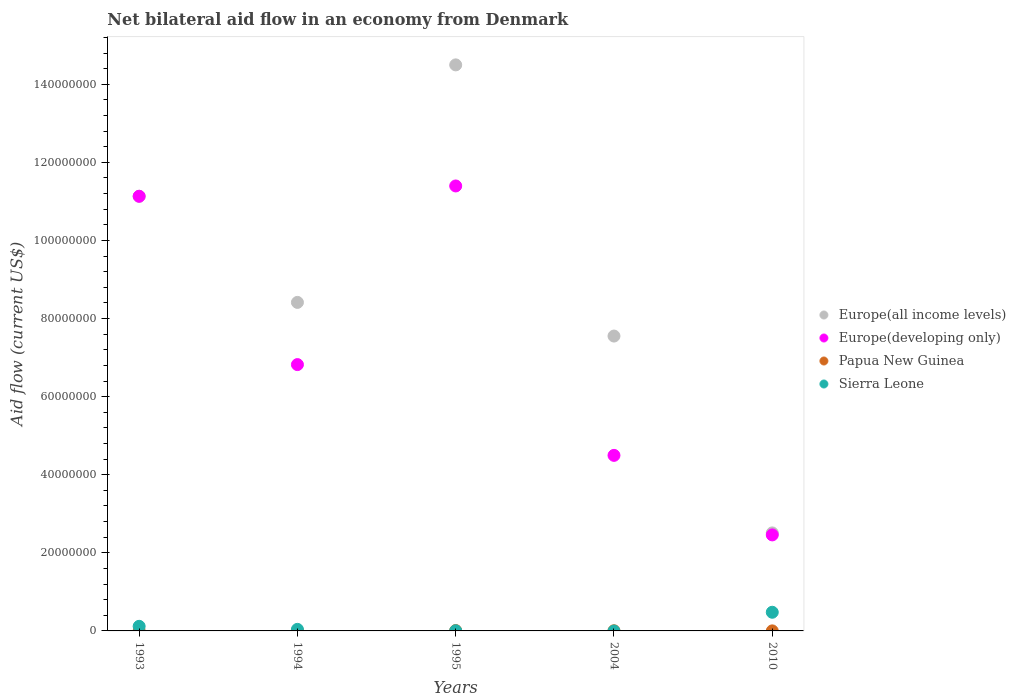What is the net bilateral aid flow in Europe(developing only) in 2004?
Offer a very short reply. 4.50e+07. Across all years, what is the maximum net bilateral aid flow in Europe(all income levels)?
Your response must be concise. 1.45e+08. Across all years, what is the minimum net bilateral aid flow in Papua New Guinea?
Provide a short and direct response. 10000. In which year was the net bilateral aid flow in Sierra Leone maximum?
Provide a succinct answer. 2010. What is the total net bilateral aid flow in Europe(all income levels) in the graph?
Make the answer very short. 4.41e+08. What is the difference between the net bilateral aid flow in Europe(developing only) in 1995 and that in 2004?
Your answer should be compact. 6.90e+07. What is the difference between the net bilateral aid flow in Europe(developing only) in 1993 and the net bilateral aid flow in Europe(all income levels) in 2010?
Ensure brevity in your answer.  8.62e+07. What is the average net bilateral aid flow in Papua New Guinea per year?
Your answer should be very brief. 3.20e+04. In how many years, is the net bilateral aid flow in Sierra Leone greater than 16000000 US$?
Keep it short and to the point. 0. What is the difference between the highest and the second highest net bilateral aid flow in Europe(developing only)?
Provide a succinct answer. 2.64e+06. What is the difference between the highest and the lowest net bilateral aid flow in Europe(all income levels)?
Your answer should be compact. 1.20e+08. Is the sum of the net bilateral aid flow in Europe(all income levels) in 1993 and 2004 greater than the maximum net bilateral aid flow in Sierra Leone across all years?
Give a very brief answer. Yes. Is it the case that in every year, the sum of the net bilateral aid flow in Europe(all income levels) and net bilateral aid flow in Papua New Guinea  is greater than the sum of net bilateral aid flow in Sierra Leone and net bilateral aid flow in Europe(developing only)?
Your answer should be very brief. Yes. Is the net bilateral aid flow in Europe(developing only) strictly greater than the net bilateral aid flow in Papua New Guinea over the years?
Make the answer very short. Yes. Is the net bilateral aid flow in Europe(developing only) strictly less than the net bilateral aid flow in Papua New Guinea over the years?
Offer a very short reply. No. What is the difference between two consecutive major ticks on the Y-axis?
Make the answer very short. 2.00e+07. Are the values on the major ticks of Y-axis written in scientific E-notation?
Provide a short and direct response. No. Does the graph contain any zero values?
Provide a succinct answer. Yes. Does the graph contain grids?
Your answer should be very brief. No. How many legend labels are there?
Ensure brevity in your answer.  4. What is the title of the graph?
Your answer should be compact. Net bilateral aid flow in an economy from Denmark. Does "Swaziland" appear as one of the legend labels in the graph?
Make the answer very short. No. What is the label or title of the Y-axis?
Ensure brevity in your answer.  Aid flow (current US$). What is the Aid flow (current US$) of Europe(all income levels) in 1993?
Ensure brevity in your answer.  1.11e+08. What is the Aid flow (current US$) in Europe(developing only) in 1993?
Your answer should be compact. 1.11e+08. What is the Aid flow (current US$) of Sierra Leone in 1993?
Provide a short and direct response. 1.18e+06. What is the Aid flow (current US$) in Europe(all income levels) in 1994?
Offer a very short reply. 8.41e+07. What is the Aid flow (current US$) of Europe(developing only) in 1994?
Provide a short and direct response. 6.82e+07. What is the Aid flow (current US$) of Papua New Guinea in 1994?
Ensure brevity in your answer.  10000. What is the Aid flow (current US$) in Europe(all income levels) in 1995?
Provide a succinct answer. 1.45e+08. What is the Aid flow (current US$) of Europe(developing only) in 1995?
Offer a terse response. 1.14e+08. What is the Aid flow (current US$) in Papua New Guinea in 1995?
Keep it short and to the point. 9.00e+04. What is the Aid flow (current US$) of Sierra Leone in 1995?
Offer a very short reply. 4.00e+04. What is the Aid flow (current US$) of Europe(all income levels) in 2004?
Your answer should be very brief. 7.55e+07. What is the Aid flow (current US$) in Europe(developing only) in 2004?
Offer a terse response. 4.50e+07. What is the Aid flow (current US$) of Sierra Leone in 2004?
Your answer should be very brief. 0. What is the Aid flow (current US$) in Europe(all income levels) in 2010?
Your answer should be compact. 2.51e+07. What is the Aid flow (current US$) of Europe(developing only) in 2010?
Your response must be concise. 2.46e+07. What is the Aid flow (current US$) in Sierra Leone in 2010?
Keep it short and to the point. 4.78e+06. Across all years, what is the maximum Aid flow (current US$) of Europe(all income levels)?
Provide a succinct answer. 1.45e+08. Across all years, what is the maximum Aid flow (current US$) in Europe(developing only)?
Provide a short and direct response. 1.14e+08. Across all years, what is the maximum Aid flow (current US$) of Papua New Guinea?
Ensure brevity in your answer.  9.00e+04. Across all years, what is the maximum Aid flow (current US$) of Sierra Leone?
Your answer should be compact. 4.78e+06. Across all years, what is the minimum Aid flow (current US$) in Europe(all income levels)?
Your response must be concise. 2.51e+07. Across all years, what is the minimum Aid flow (current US$) in Europe(developing only)?
Provide a succinct answer. 2.46e+07. Across all years, what is the minimum Aid flow (current US$) of Papua New Guinea?
Keep it short and to the point. 10000. Across all years, what is the minimum Aid flow (current US$) of Sierra Leone?
Keep it short and to the point. 0. What is the total Aid flow (current US$) in Europe(all income levels) in the graph?
Offer a very short reply. 4.41e+08. What is the total Aid flow (current US$) of Europe(developing only) in the graph?
Ensure brevity in your answer.  3.63e+08. What is the total Aid flow (current US$) of Papua New Guinea in the graph?
Give a very brief answer. 1.60e+05. What is the total Aid flow (current US$) of Sierra Leone in the graph?
Provide a succinct answer. 6.40e+06. What is the difference between the Aid flow (current US$) in Europe(all income levels) in 1993 and that in 1994?
Provide a short and direct response. 2.72e+07. What is the difference between the Aid flow (current US$) of Europe(developing only) in 1993 and that in 1994?
Provide a succinct answer. 4.31e+07. What is the difference between the Aid flow (current US$) of Papua New Guinea in 1993 and that in 1994?
Give a very brief answer. 0. What is the difference between the Aid flow (current US$) of Sierra Leone in 1993 and that in 1994?
Offer a terse response. 7.80e+05. What is the difference between the Aid flow (current US$) of Europe(all income levels) in 1993 and that in 1995?
Offer a very short reply. -3.36e+07. What is the difference between the Aid flow (current US$) in Europe(developing only) in 1993 and that in 1995?
Provide a short and direct response. -2.64e+06. What is the difference between the Aid flow (current US$) of Sierra Leone in 1993 and that in 1995?
Provide a short and direct response. 1.14e+06. What is the difference between the Aid flow (current US$) in Europe(all income levels) in 1993 and that in 2004?
Offer a very short reply. 3.58e+07. What is the difference between the Aid flow (current US$) in Europe(developing only) in 1993 and that in 2004?
Ensure brevity in your answer.  6.64e+07. What is the difference between the Aid flow (current US$) of Europe(all income levels) in 1993 and that in 2010?
Provide a succinct answer. 8.62e+07. What is the difference between the Aid flow (current US$) of Europe(developing only) in 1993 and that in 2010?
Provide a short and direct response. 8.67e+07. What is the difference between the Aid flow (current US$) in Sierra Leone in 1993 and that in 2010?
Provide a short and direct response. -3.60e+06. What is the difference between the Aid flow (current US$) of Europe(all income levels) in 1994 and that in 1995?
Offer a terse response. -6.08e+07. What is the difference between the Aid flow (current US$) of Europe(developing only) in 1994 and that in 1995?
Give a very brief answer. -4.58e+07. What is the difference between the Aid flow (current US$) in Papua New Guinea in 1994 and that in 1995?
Your answer should be very brief. -8.00e+04. What is the difference between the Aid flow (current US$) of Sierra Leone in 1994 and that in 1995?
Offer a terse response. 3.60e+05. What is the difference between the Aid flow (current US$) of Europe(all income levels) in 1994 and that in 2004?
Offer a very short reply. 8.62e+06. What is the difference between the Aid flow (current US$) of Europe(developing only) in 1994 and that in 2004?
Provide a succinct answer. 2.32e+07. What is the difference between the Aid flow (current US$) in Papua New Guinea in 1994 and that in 2004?
Your response must be concise. -3.00e+04. What is the difference between the Aid flow (current US$) in Europe(all income levels) in 1994 and that in 2010?
Your answer should be compact. 5.90e+07. What is the difference between the Aid flow (current US$) of Europe(developing only) in 1994 and that in 2010?
Make the answer very short. 4.36e+07. What is the difference between the Aid flow (current US$) of Papua New Guinea in 1994 and that in 2010?
Provide a succinct answer. 0. What is the difference between the Aid flow (current US$) of Sierra Leone in 1994 and that in 2010?
Give a very brief answer. -4.38e+06. What is the difference between the Aid flow (current US$) of Europe(all income levels) in 1995 and that in 2004?
Your response must be concise. 6.94e+07. What is the difference between the Aid flow (current US$) of Europe(developing only) in 1995 and that in 2004?
Ensure brevity in your answer.  6.90e+07. What is the difference between the Aid flow (current US$) in Papua New Guinea in 1995 and that in 2004?
Provide a short and direct response. 5.00e+04. What is the difference between the Aid flow (current US$) of Europe(all income levels) in 1995 and that in 2010?
Provide a short and direct response. 1.20e+08. What is the difference between the Aid flow (current US$) of Europe(developing only) in 1995 and that in 2010?
Offer a terse response. 8.94e+07. What is the difference between the Aid flow (current US$) of Papua New Guinea in 1995 and that in 2010?
Offer a terse response. 8.00e+04. What is the difference between the Aid flow (current US$) in Sierra Leone in 1995 and that in 2010?
Provide a succinct answer. -4.74e+06. What is the difference between the Aid flow (current US$) of Europe(all income levels) in 2004 and that in 2010?
Your response must be concise. 5.04e+07. What is the difference between the Aid flow (current US$) of Europe(developing only) in 2004 and that in 2010?
Give a very brief answer. 2.04e+07. What is the difference between the Aid flow (current US$) in Papua New Guinea in 2004 and that in 2010?
Keep it short and to the point. 3.00e+04. What is the difference between the Aid flow (current US$) of Europe(all income levels) in 1993 and the Aid flow (current US$) of Europe(developing only) in 1994?
Keep it short and to the point. 4.31e+07. What is the difference between the Aid flow (current US$) of Europe(all income levels) in 1993 and the Aid flow (current US$) of Papua New Guinea in 1994?
Ensure brevity in your answer.  1.11e+08. What is the difference between the Aid flow (current US$) in Europe(all income levels) in 1993 and the Aid flow (current US$) in Sierra Leone in 1994?
Your response must be concise. 1.11e+08. What is the difference between the Aid flow (current US$) in Europe(developing only) in 1993 and the Aid flow (current US$) in Papua New Guinea in 1994?
Your response must be concise. 1.11e+08. What is the difference between the Aid flow (current US$) in Europe(developing only) in 1993 and the Aid flow (current US$) in Sierra Leone in 1994?
Offer a very short reply. 1.11e+08. What is the difference between the Aid flow (current US$) of Papua New Guinea in 1993 and the Aid flow (current US$) of Sierra Leone in 1994?
Your answer should be compact. -3.90e+05. What is the difference between the Aid flow (current US$) in Europe(all income levels) in 1993 and the Aid flow (current US$) in Europe(developing only) in 1995?
Ensure brevity in your answer.  -2.64e+06. What is the difference between the Aid flow (current US$) of Europe(all income levels) in 1993 and the Aid flow (current US$) of Papua New Guinea in 1995?
Give a very brief answer. 1.11e+08. What is the difference between the Aid flow (current US$) in Europe(all income levels) in 1993 and the Aid flow (current US$) in Sierra Leone in 1995?
Keep it short and to the point. 1.11e+08. What is the difference between the Aid flow (current US$) in Europe(developing only) in 1993 and the Aid flow (current US$) in Papua New Guinea in 1995?
Give a very brief answer. 1.11e+08. What is the difference between the Aid flow (current US$) in Europe(developing only) in 1993 and the Aid flow (current US$) in Sierra Leone in 1995?
Offer a terse response. 1.11e+08. What is the difference between the Aid flow (current US$) in Papua New Guinea in 1993 and the Aid flow (current US$) in Sierra Leone in 1995?
Give a very brief answer. -3.00e+04. What is the difference between the Aid flow (current US$) in Europe(all income levels) in 1993 and the Aid flow (current US$) in Europe(developing only) in 2004?
Provide a short and direct response. 6.64e+07. What is the difference between the Aid flow (current US$) of Europe(all income levels) in 1993 and the Aid flow (current US$) of Papua New Guinea in 2004?
Make the answer very short. 1.11e+08. What is the difference between the Aid flow (current US$) in Europe(developing only) in 1993 and the Aid flow (current US$) in Papua New Guinea in 2004?
Ensure brevity in your answer.  1.11e+08. What is the difference between the Aid flow (current US$) in Europe(all income levels) in 1993 and the Aid flow (current US$) in Europe(developing only) in 2010?
Provide a short and direct response. 8.67e+07. What is the difference between the Aid flow (current US$) of Europe(all income levels) in 1993 and the Aid flow (current US$) of Papua New Guinea in 2010?
Your answer should be compact. 1.11e+08. What is the difference between the Aid flow (current US$) of Europe(all income levels) in 1993 and the Aid flow (current US$) of Sierra Leone in 2010?
Make the answer very short. 1.07e+08. What is the difference between the Aid flow (current US$) in Europe(developing only) in 1993 and the Aid flow (current US$) in Papua New Guinea in 2010?
Your answer should be very brief. 1.11e+08. What is the difference between the Aid flow (current US$) of Europe(developing only) in 1993 and the Aid flow (current US$) of Sierra Leone in 2010?
Give a very brief answer. 1.07e+08. What is the difference between the Aid flow (current US$) in Papua New Guinea in 1993 and the Aid flow (current US$) in Sierra Leone in 2010?
Your answer should be compact. -4.77e+06. What is the difference between the Aid flow (current US$) in Europe(all income levels) in 1994 and the Aid flow (current US$) in Europe(developing only) in 1995?
Ensure brevity in your answer.  -2.98e+07. What is the difference between the Aid flow (current US$) in Europe(all income levels) in 1994 and the Aid flow (current US$) in Papua New Guinea in 1995?
Your response must be concise. 8.40e+07. What is the difference between the Aid flow (current US$) in Europe(all income levels) in 1994 and the Aid flow (current US$) in Sierra Leone in 1995?
Offer a terse response. 8.41e+07. What is the difference between the Aid flow (current US$) in Europe(developing only) in 1994 and the Aid flow (current US$) in Papua New Guinea in 1995?
Ensure brevity in your answer.  6.81e+07. What is the difference between the Aid flow (current US$) in Europe(developing only) in 1994 and the Aid flow (current US$) in Sierra Leone in 1995?
Keep it short and to the point. 6.82e+07. What is the difference between the Aid flow (current US$) of Papua New Guinea in 1994 and the Aid flow (current US$) of Sierra Leone in 1995?
Offer a terse response. -3.00e+04. What is the difference between the Aid flow (current US$) in Europe(all income levels) in 1994 and the Aid flow (current US$) in Europe(developing only) in 2004?
Provide a short and direct response. 3.92e+07. What is the difference between the Aid flow (current US$) in Europe(all income levels) in 1994 and the Aid flow (current US$) in Papua New Guinea in 2004?
Your answer should be compact. 8.41e+07. What is the difference between the Aid flow (current US$) in Europe(developing only) in 1994 and the Aid flow (current US$) in Papua New Guinea in 2004?
Make the answer very short. 6.82e+07. What is the difference between the Aid flow (current US$) in Europe(all income levels) in 1994 and the Aid flow (current US$) in Europe(developing only) in 2010?
Make the answer very short. 5.96e+07. What is the difference between the Aid flow (current US$) in Europe(all income levels) in 1994 and the Aid flow (current US$) in Papua New Guinea in 2010?
Make the answer very short. 8.41e+07. What is the difference between the Aid flow (current US$) in Europe(all income levels) in 1994 and the Aid flow (current US$) in Sierra Leone in 2010?
Provide a succinct answer. 7.94e+07. What is the difference between the Aid flow (current US$) of Europe(developing only) in 1994 and the Aid flow (current US$) of Papua New Guinea in 2010?
Give a very brief answer. 6.82e+07. What is the difference between the Aid flow (current US$) in Europe(developing only) in 1994 and the Aid flow (current US$) in Sierra Leone in 2010?
Your response must be concise. 6.34e+07. What is the difference between the Aid flow (current US$) in Papua New Guinea in 1994 and the Aid flow (current US$) in Sierra Leone in 2010?
Provide a short and direct response. -4.77e+06. What is the difference between the Aid flow (current US$) in Europe(all income levels) in 1995 and the Aid flow (current US$) in Europe(developing only) in 2004?
Provide a succinct answer. 1.00e+08. What is the difference between the Aid flow (current US$) of Europe(all income levels) in 1995 and the Aid flow (current US$) of Papua New Guinea in 2004?
Keep it short and to the point. 1.45e+08. What is the difference between the Aid flow (current US$) in Europe(developing only) in 1995 and the Aid flow (current US$) in Papua New Guinea in 2004?
Offer a terse response. 1.14e+08. What is the difference between the Aid flow (current US$) of Europe(all income levels) in 1995 and the Aid flow (current US$) of Europe(developing only) in 2010?
Ensure brevity in your answer.  1.20e+08. What is the difference between the Aid flow (current US$) in Europe(all income levels) in 1995 and the Aid flow (current US$) in Papua New Guinea in 2010?
Offer a very short reply. 1.45e+08. What is the difference between the Aid flow (current US$) of Europe(all income levels) in 1995 and the Aid flow (current US$) of Sierra Leone in 2010?
Make the answer very short. 1.40e+08. What is the difference between the Aid flow (current US$) in Europe(developing only) in 1995 and the Aid flow (current US$) in Papua New Guinea in 2010?
Your answer should be compact. 1.14e+08. What is the difference between the Aid flow (current US$) in Europe(developing only) in 1995 and the Aid flow (current US$) in Sierra Leone in 2010?
Offer a very short reply. 1.09e+08. What is the difference between the Aid flow (current US$) in Papua New Guinea in 1995 and the Aid flow (current US$) in Sierra Leone in 2010?
Give a very brief answer. -4.69e+06. What is the difference between the Aid flow (current US$) of Europe(all income levels) in 2004 and the Aid flow (current US$) of Europe(developing only) in 2010?
Your answer should be compact. 5.09e+07. What is the difference between the Aid flow (current US$) in Europe(all income levels) in 2004 and the Aid flow (current US$) in Papua New Guinea in 2010?
Make the answer very short. 7.55e+07. What is the difference between the Aid flow (current US$) in Europe(all income levels) in 2004 and the Aid flow (current US$) in Sierra Leone in 2010?
Provide a succinct answer. 7.07e+07. What is the difference between the Aid flow (current US$) in Europe(developing only) in 2004 and the Aid flow (current US$) in Papua New Guinea in 2010?
Your response must be concise. 4.50e+07. What is the difference between the Aid flow (current US$) in Europe(developing only) in 2004 and the Aid flow (current US$) in Sierra Leone in 2010?
Your answer should be compact. 4.02e+07. What is the difference between the Aid flow (current US$) of Papua New Guinea in 2004 and the Aid flow (current US$) of Sierra Leone in 2010?
Your answer should be very brief. -4.74e+06. What is the average Aid flow (current US$) of Europe(all income levels) per year?
Your answer should be very brief. 8.82e+07. What is the average Aid flow (current US$) of Europe(developing only) per year?
Give a very brief answer. 7.26e+07. What is the average Aid flow (current US$) of Papua New Guinea per year?
Your response must be concise. 3.20e+04. What is the average Aid flow (current US$) of Sierra Leone per year?
Your answer should be compact. 1.28e+06. In the year 1993, what is the difference between the Aid flow (current US$) in Europe(all income levels) and Aid flow (current US$) in Europe(developing only)?
Offer a terse response. 0. In the year 1993, what is the difference between the Aid flow (current US$) in Europe(all income levels) and Aid flow (current US$) in Papua New Guinea?
Make the answer very short. 1.11e+08. In the year 1993, what is the difference between the Aid flow (current US$) in Europe(all income levels) and Aid flow (current US$) in Sierra Leone?
Your answer should be compact. 1.10e+08. In the year 1993, what is the difference between the Aid flow (current US$) in Europe(developing only) and Aid flow (current US$) in Papua New Guinea?
Your answer should be very brief. 1.11e+08. In the year 1993, what is the difference between the Aid flow (current US$) of Europe(developing only) and Aid flow (current US$) of Sierra Leone?
Ensure brevity in your answer.  1.10e+08. In the year 1993, what is the difference between the Aid flow (current US$) in Papua New Guinea and Aid flow (current US$) in Sierra Leone?
Provide a short and direct response. -1.17e+06. In the year 1994, what is the difference between the Aid flow (current US$) in Europe(all income levels) and Aid flow (current US$) in Europe(developing only)?
Provide a short and direct response. 1.59e+07. In the year 1994, what is the difference between the Aid flow (current US$) in Europe(all income levels) and Aid flow (current US$) in Papua New Guinea?
Your response must be concise. 8.41e+07. In the year 1994, what is the difference between the Aid flow (current US$) in Europe(all income levels) and Aid flow (current US$) in Sierra Leone?
Your response must be concise. 8.37e+07. In the year 1994, what is the difference between the Aid flow (current US$) in Europe(developing only) and Aid flow (current US$) in Papua New Guinea?
Your response must be concise. 6.82e+07. In the year 1994, what is the difference between the Aid flow (current US$) in Europe(developing only) and Aid flow (current US$) in Sierra Leone?
Your answer should be very brief. 6.78e+07. In the year 1994, what is the difference between the Aid flow (current US$) in Papua New Guinea and Aid flow (current US$) in Sierra Leone?
Provide a succinct answer. -3.90e+05. In the year 1995, what is the difference between the Aid flow (current US$) in Europe(all income levels) and Aid flow (current US$) in Europe(developing only)?
Give a very brief answer. 3.10e+07. In the year 1995, what is the difference between the Aid flow (current US$) of Europe(all income levels) and Aid flow (current US$) of Papua New Guinea?
Give a very brief answer. 1.45e+08. In the year 1995, what is the difference between the Aid flow (current US$) of Europe(all income levels) and Aid flow (current US$) of Sierra Leone?
Keep it short and to the point. 1.45e+08. In the year 1995, what is the difference between the Aid flow (current US$) in Europe(developing only) and Aid flow (current US$) in Papua New Guinea?
Your response must be concise. 1.14e+08. In the year 1995, what is the difference between the Aid flow (current US$) in Europe(developing only) and Aid flow (current US$) in Sierra Leone?
Your response must be concise. 1.14e+08. In the year 1995, what is the difference between the Aid flow (current US$) in Papua New Guinea and Aid flow (current US$) in Sierra Leone?
Ensure brevity in your answer.  5.00e+04. In the year 2004, what is the difference between the Aid flow (current US$) in Europe(all income levels) and Aid flow (current US$) in Europe(developing only)?
Your response must be concise. 3.06e+07. In the year 2004, what is the difference between the Aid flow (current US$) in Europe(all income levels) and Aid flow (current US$) in Papua New Guinea?
Ensure brevity in your answer.  7.55e+07. In the year 2004, what is the difference between the Aid flow (current US$) in Europe(developing only) and Aid flow (current US$) in Papua New Guinea?
Your answer should be compact. 4.49e+07. In the year 2010, what is the difference between the Aid flow (current US$) in Europe(all income levels) and Aid flow (current US$) in Europe(developing only)?
Keep it short and to the point. 5.10e+05. In the year 2010, what is the difference between the Aid flow (current US$) in Europe(all income levels) and Aid flow (current US$) in Papua New Guinea?
Offer a very short reply. 2.51e+07. In the year 2010, what is the difference between the Aid flow (current US$) in Europe(all income levels) and Aid flow (current US$) in Sierra Leone?
Keep it short and to the point. 2.03e+07. In the year 2010, what is the difference between the Aid flow (current US$) in Europe(developing only) and Aid flow (current US$) in Papua New Guinea?
Ensure brevity in your answer.  2.46e+07. In the year 2010, what is the difference between the Aid flow (current US$) of Europe(developing only) and Aid flow (current US$) of Sierra Leone?
Provide a succinct answer. 1.98e+07. In the year 2010, what is the difference between the Aid flow (current US$) of Papua New Guinea and Aid flow (current US$) of Sierra Leone?
Your response must be concise. -4.77e+06. What is the ratio of the Aid flow (current US$) in Europe(all income levels) in 1993 to that in 1994?
Your answer should be compact. 1.32. What is the ratio of the Aid flow (current US$) of Europe(developing only) in 1993 to that in 1994?
Provide a succinct answer. 1.63. What is the ratio of the Aid flow (current US$) of Papua New Guinea in 1993 to that in 1994?
Your response must be concise. 1. What is the ratio of the Aid flow (current US$) in Sierra Leone in 1993 to that in 1994?
Give a very brief answer. 2.95. What is the ratio of the Aid flow (current US$) of Europe(all income levels) in 1993 to that in 1995?
Keep it short and to the point. 0.77. What is the ratio of the Aid flow (current US$) of Europe(developing only) in 1993 to that in 1995?
Keep it short and to the point. 0.98. What is the ratio of the Aid flow (current US$) in Papua New Guinea in 1993 to that in 1995?
Your answer should be compact. 0.11. What is the ratio of the Aid flow (current US$) in Sierra Leone in 1993 to that in 1995?
Provide a short and direct response. 29.5. What is the ratio of the Aid flow (current US$) in Europe(all income levels) in 1993 to that in 2004?
Offer a very short reply. 1.47. What is the ratio of the Aid flow (current US$) of Europe(developing only) in 1993 to that in 2004?
Ensure brevity in your answer.  2.48. What is the ratio of the Aid flow (current US$) of Papua New Guinea in 1993 to that in 2004?
Make the answer very short. 0.25. What is the ratio of the Aid flow (current US$) in Europe(all income levels) in 1993 to that in 2010?
Offer a terse response. 4.44. What is the ratio of the Aid flow (current US$) of Europe(developing only) in 1993 to that in 2010?
Keep it short and to the point. 4.53. What is the ratio of the Aid flow (current US$) of Sierra Leone in 1993 to that in 2010?
Your answer should be very brief. 0.25. What is the ratio of the Aid flow (current US$) in Europe(all income levels) in 1994 to that in 1995?
Provide a succinct answer. 0.58. What is the ratio of the Aid flow (current US$) of Europe(developing only) in 1994 to that in 1995?
Provide a succinct answer. 0.6. What is the ratio of the Aid flow (current US$) of Europe(all income levels) in 1994 to that in 2004?
Your response must be concise. 1.11. What is the ratio of the Aid flow (current US$) of Europe(developing only) in 1994 to that in 2004?
Make the answer very short. 1.52. What is the ratio of the Aid flow (current US$) of Papua New Guinea in 1994 to that in 2004?
Keep it short and to the point. 0.25. What is the ratio of the Aid flow (current US$) of Europe(all income levels) in 1994 to that in 2010?
Your response must be concise. 3.35. What is the ratio of the Aid flow (current US$) in Europe(developing only) in 1994 to that in 2010?
Offer a terse response. 2.77. What is the ratio of the Aid flow (current US$) in Sierra Leone in 1994 to that in 2010?
Provide a succinct answer. 0.08. What is the ratio of the Aid flow (current US$) of Europe(all income levels) in 1995 to that in 2004?
Your answer should be very brief. 1.92. What is the ratio of the Aid flow (current US$) of Europe(developing only) in 1995 to that in 2004?
Keep it short and to the point. 2.53. What is the ratio of the Aid flow (current US$) in Papua New Guinea in 1995 to that in 2004?
Your answer should be compact. 2.25. What is the ratio of the Aid flow (current US$) of Europe(all income levels) in 1995 to that in 2010?
Offer a terse response. 5.78. What is the ratio of the Aid flow (current US$) of Europe(developing only) in 1995 to that in 2010?
Ensure brevity in your answer.  4.63. What is the ratio of the Aid flow (current US$) of Sierra Leone in 1995 to that in 2010?
Offer a terse response. 0.01. What is the ratio of the Aid flow (current US$) of Europe(all income levels) in 2004 to that in 2010?
Offer a very short reply. 3.01. What is the ratio of the Aid flow (current US$) of Europe(developing only) in 2004 to that in 2010?
Your answer should be very brief. 1.83. What is the ratio of the Aid flow (current US$) of Papua New Guinea in 2004 to that in 2010?
Ensure brevity in your answer.  4. What is the difference between the highest and the second highest Aid flow (current US$) in Europe(all income levels)?
Give a very brief answer. 3.36e+07. What is the difference between the highest and the second highest Aid flow (current US$) in Europe(developing only)?
Your response must be concise. 2.64e+06. What is the difference between the highest and the second highest Aid flow (current US$) in Sierra Leone?
Offer a terse response. 3.60e+06. What is the difference between the highest and the lowest Aid flow (current US$) in Europe(all income levels)?
Keep it short and to the point. 1.20e+08. What is the difference between the highest and the lowest Aid flow (current US$) of Europe(developing only)?
Your response must be concise. 8.94e+07. What is the difference between the highest and the lowest Aid flow (current US$) of Sierra Leone?
Your response must be concise. 4.78e+06. 